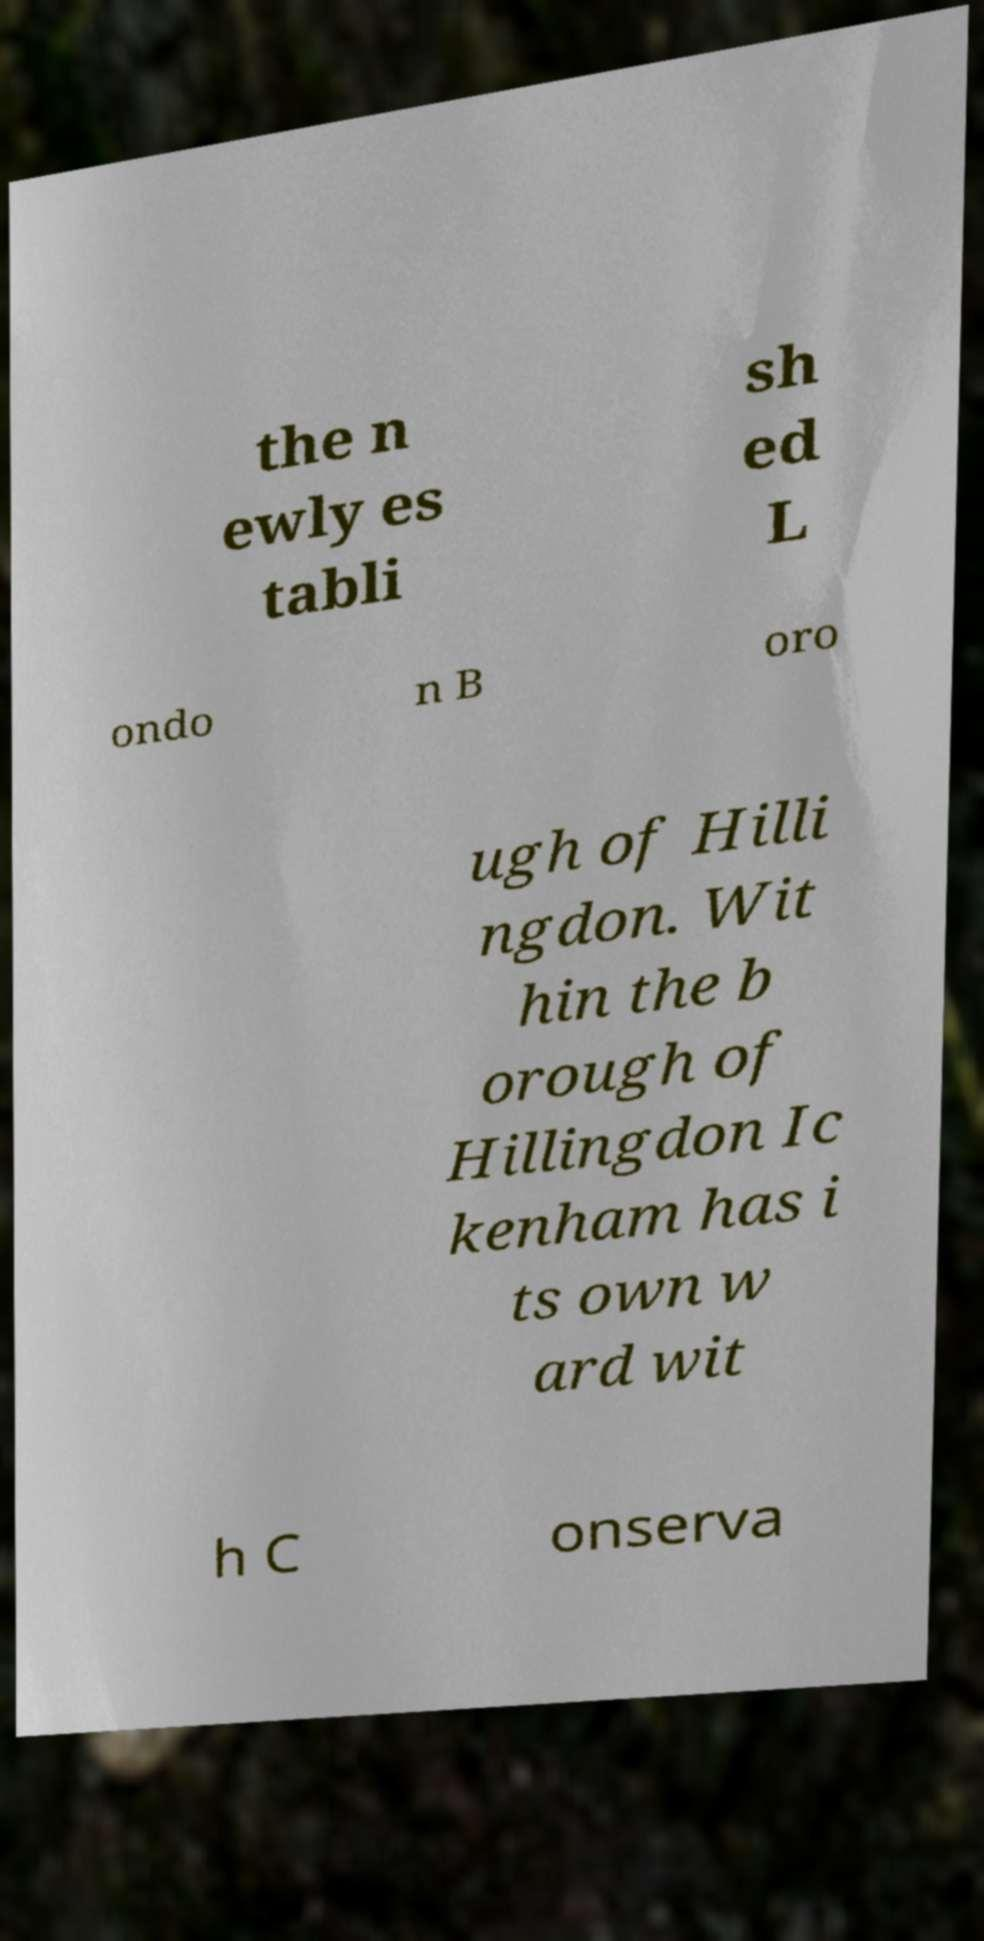Could you assist in decoding the text presented in this image and type it out clearly? the n ewly es tabli sh ed L ondo n B oro ugh of Hilli ngdon. Wit hin the b orough of Hillingdon Ic kenham has i ts own w ard wit h C onserva 